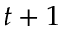Convert formula to latex. <formula><loc_0><loc_0><loc_500><loc_500>t + 1</formula> 